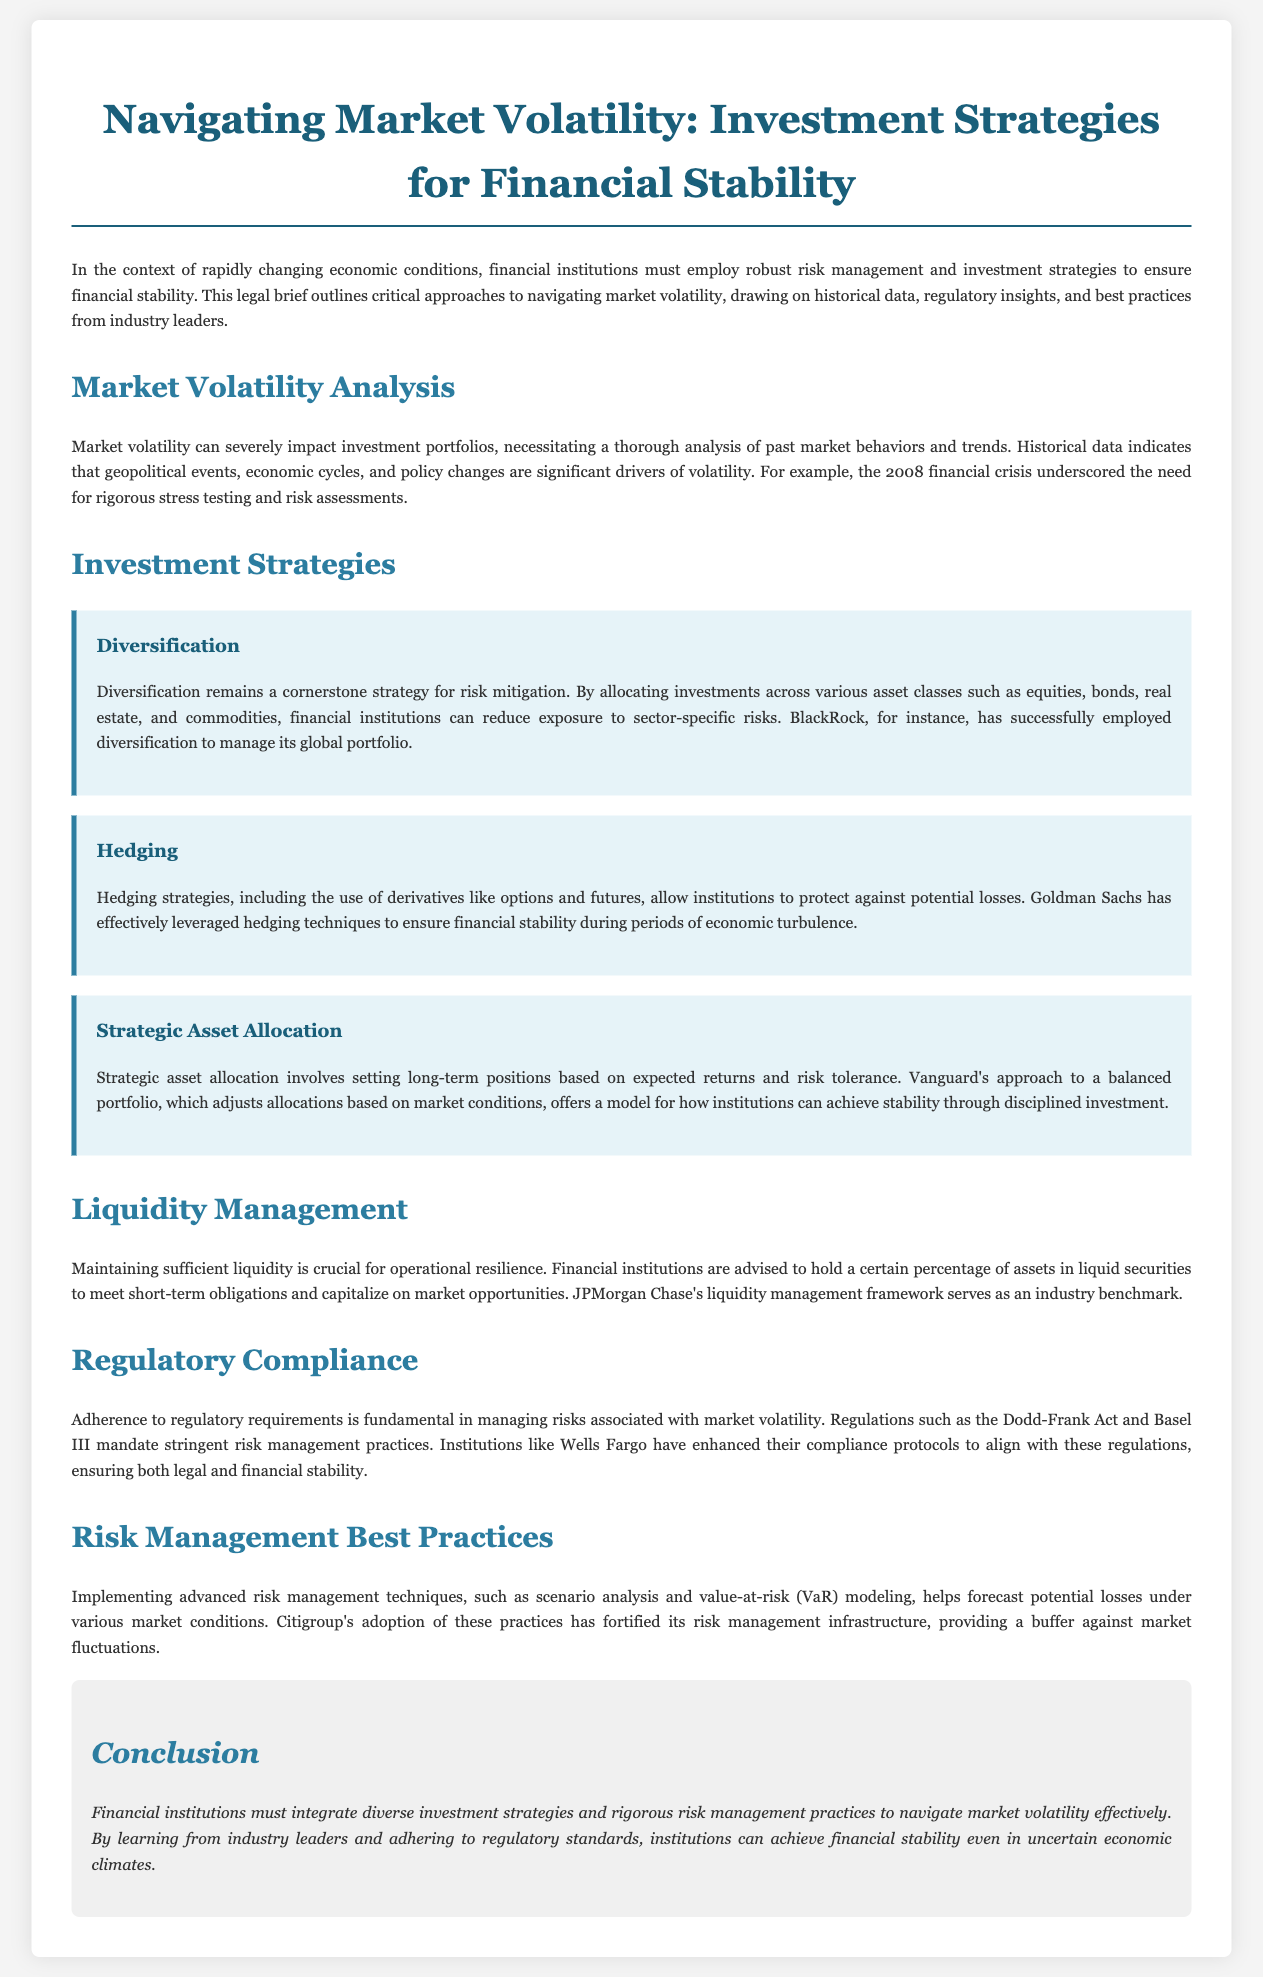What is the title of the legal brief? The title of the legal brief is provided in the document's header section.
Answer: Navigating Market Volatility: Investment Strategies for Financial Stability What is the cornerstone strategy for risk mitigation mentioned in the brief? The brief identifies a key strategy for reducing risks in investment as outlined in the Investment Strategies section.
Answer: Diversification Who effectively leveraged hedging techniques during economic turbulence? The brief provides an example of a specific institution that used hedging successfully.
Answer: Goldman Sachs What regulatory act is mentioned in relation to risk management practices? The brief lists a regulatory requirement relevant to financial institutions management practices.
Answer: Dodd-Frank Act What technique helps forecast potential losses under various market conditions? The document discusses advanced risk management techniques and mentions a specific one that aids in forecasting losses.
Answer: Value-at-risk (VaR) modeling Which financial institution serves as an industry benchmark for liquidity management? The brief highlights a specific institution recognized for its exemplary liquidity management framework.
Answer: JPMorgan Chase What approach does Vanguard use to adjust allocations based on market conditions? The brief describes a specific method undertaken by an institution to attain stability.
Answer: Balanced portfolio What year did the financial crisis that underscored the need for risk assessments occur? The brief cites a significant event illustrating the importance of stress testing and risk assessments.
Answer: 2008 What is essential for operational resilience according to the document? The brief outlines a critical aspect for the stability of financial institutions.
Answer: Sufficient liquidity 